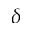Convert formula to latex. <formula><loc_0><loc_0><loc_500><loc_500>\delta</formula> 